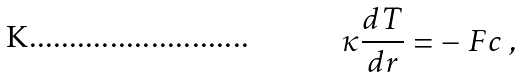<formula> <loc_0><loc_0><loc_500><loc_500>\kappa \frac { d T } { d r } = - \ F c \ ,</formula> 